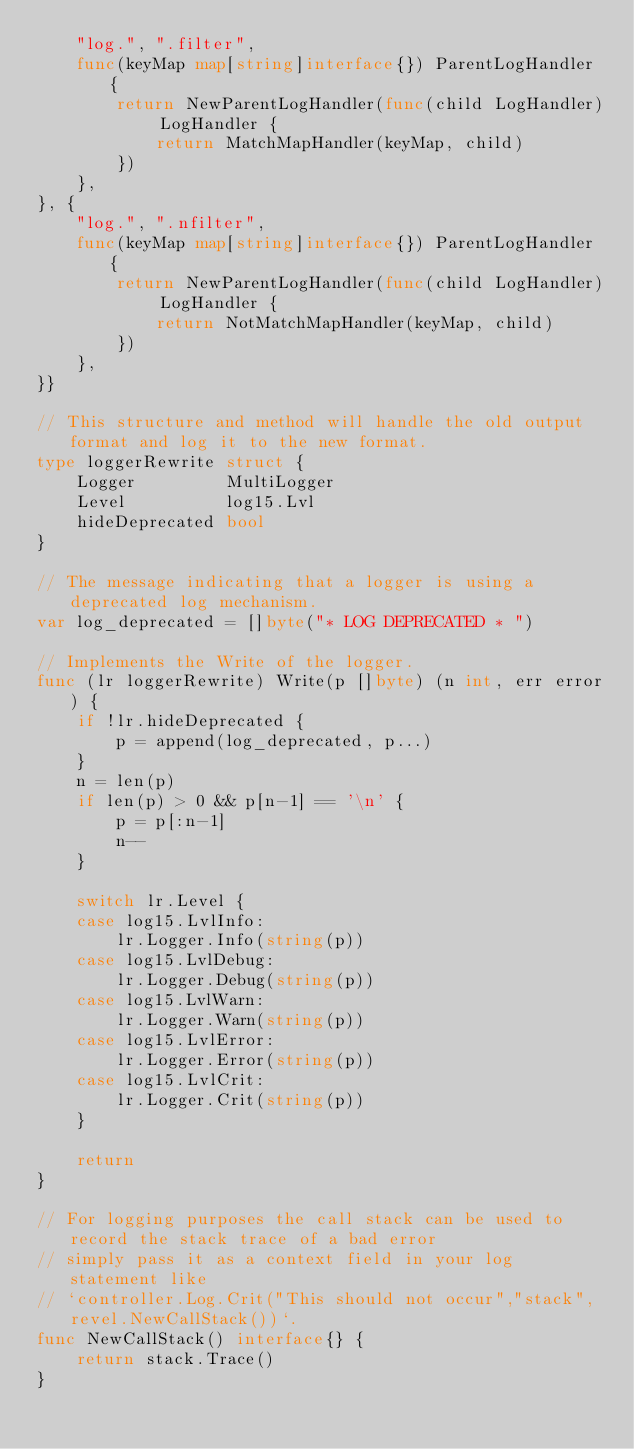<code> <loc_0><loc_0><loc_500><loc_500><_Go_>	"log.", ".filter",
	func(keyMap map[string]interface{}) ParentLogHandler {
		return NewParentLogHandler(func(child LogHandler) LogHandler {
			return MatchMapHandler(keyMap, child)
		})
	},
}, {
	"log.", ".nfilter",
	func(keyMap map[string]interface{}) ParentLogHandler {
		return NewParentLogHandler(func(child LogHandler) LogHandler {
			return NotMatchMapHandler(keyMap, child)
		})
	},
}}

// This structure and method will handle the old output format and log it to the new format.
type loggerRewrite struct {
	Logger         MultiLogger
	Level          log15.Lvl
	hideDeprecated bool
}

// The message indicating that a logger is using a deprecated log mechanism.
var log_deprecated = []byte("* LOG DEPRECATED * ")

// Implements the Write of the logger.
func (lr loggerRewrite) Write(p []byte) (n int, err error) {
	if !lr.hideDeprecated {
		p = append(log_deprecated, p...)
	}
	n = len(p)
	if len(p) > 0 && p[n-1] == '\n' {
		p = p[:n-1]
		n--
	}

	switch lr.Level {
	case log15.LvlInfo:
		lr.Logger.Info(string(p))
	case log15.LvlDebug:
		lr.Logger.Debug(string(p))
	case log15.LvlWarn:
		lr.Logger.Warn(string(p))
	case log15.LvlError:
		lr.Logger.Error(string(p))
	case log15.LvlCrit:
		lr.Logger.Crit(string(p))
	}

	return
}

// For logging purposes the call stack can be used to record the stack trace of a bad error
// simply pass it as a context field in your log statement like
// `controller.Log.Crit("This should not occur","stack",revel.NewCallStack())`.
func NewCallStack() interface{} {
	return stack.Trace()
}
</code> 